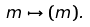<formula> <loc_0><loc_0><loc_500><loc_500>m \mapsto ( m ) .</formula> 